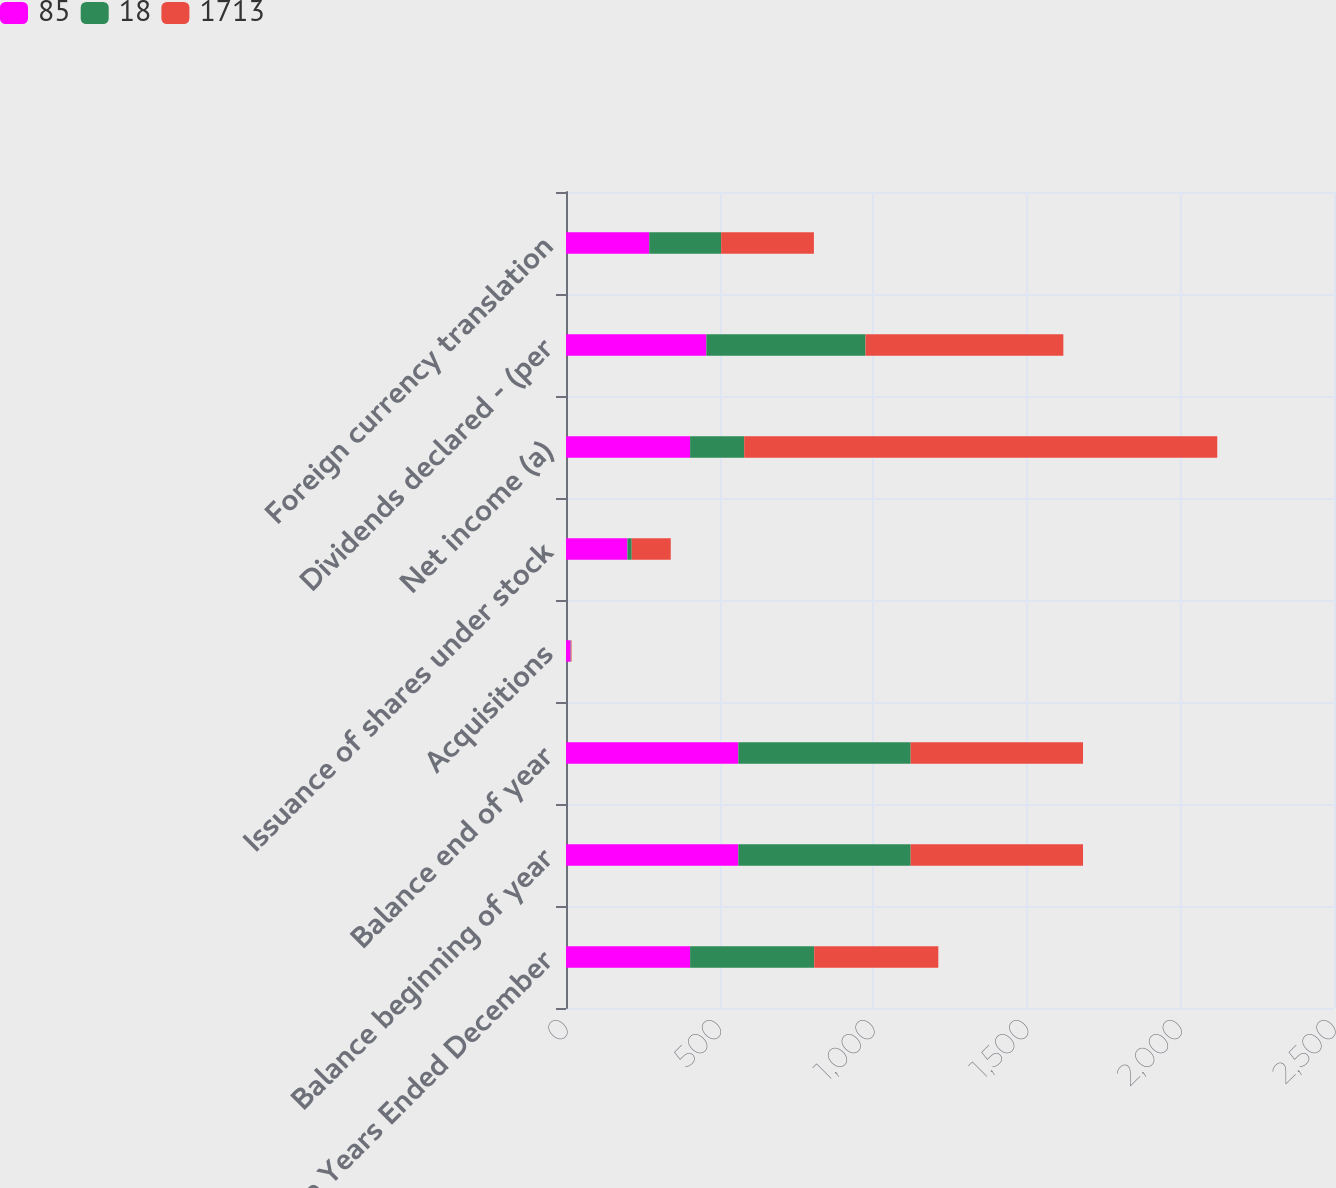<chart> <loc_0><loc_0><loc_500><loc_500><stacked_bar_chart><ecel><fcel>For the Years Ended December<fcel>Balance beginning of year<fcel>Balance end of year<fcel>Acquisitions<fcel>Issuance of shares under stock<fcel>Net income (a)<fcel>Dividends declared - (per<fcel>Foreign currency translation<nl><fcel>85<fcel>404<fcel>561<fcel>561<fcel>15<fcel>200<fcel>404<fcel>457<fcel>271<nl><fcel>18<fcel>404<fcel>561<fcel>561<fcel>1<fcel>14<fcel>176<fcel>518<fcel>234<nl><fcel>1713<fcel>404<fcel>561<fcel>561<fcel>2<fcel>127<fcel>1540<fcel>644<fcel>302<nl></chart> 